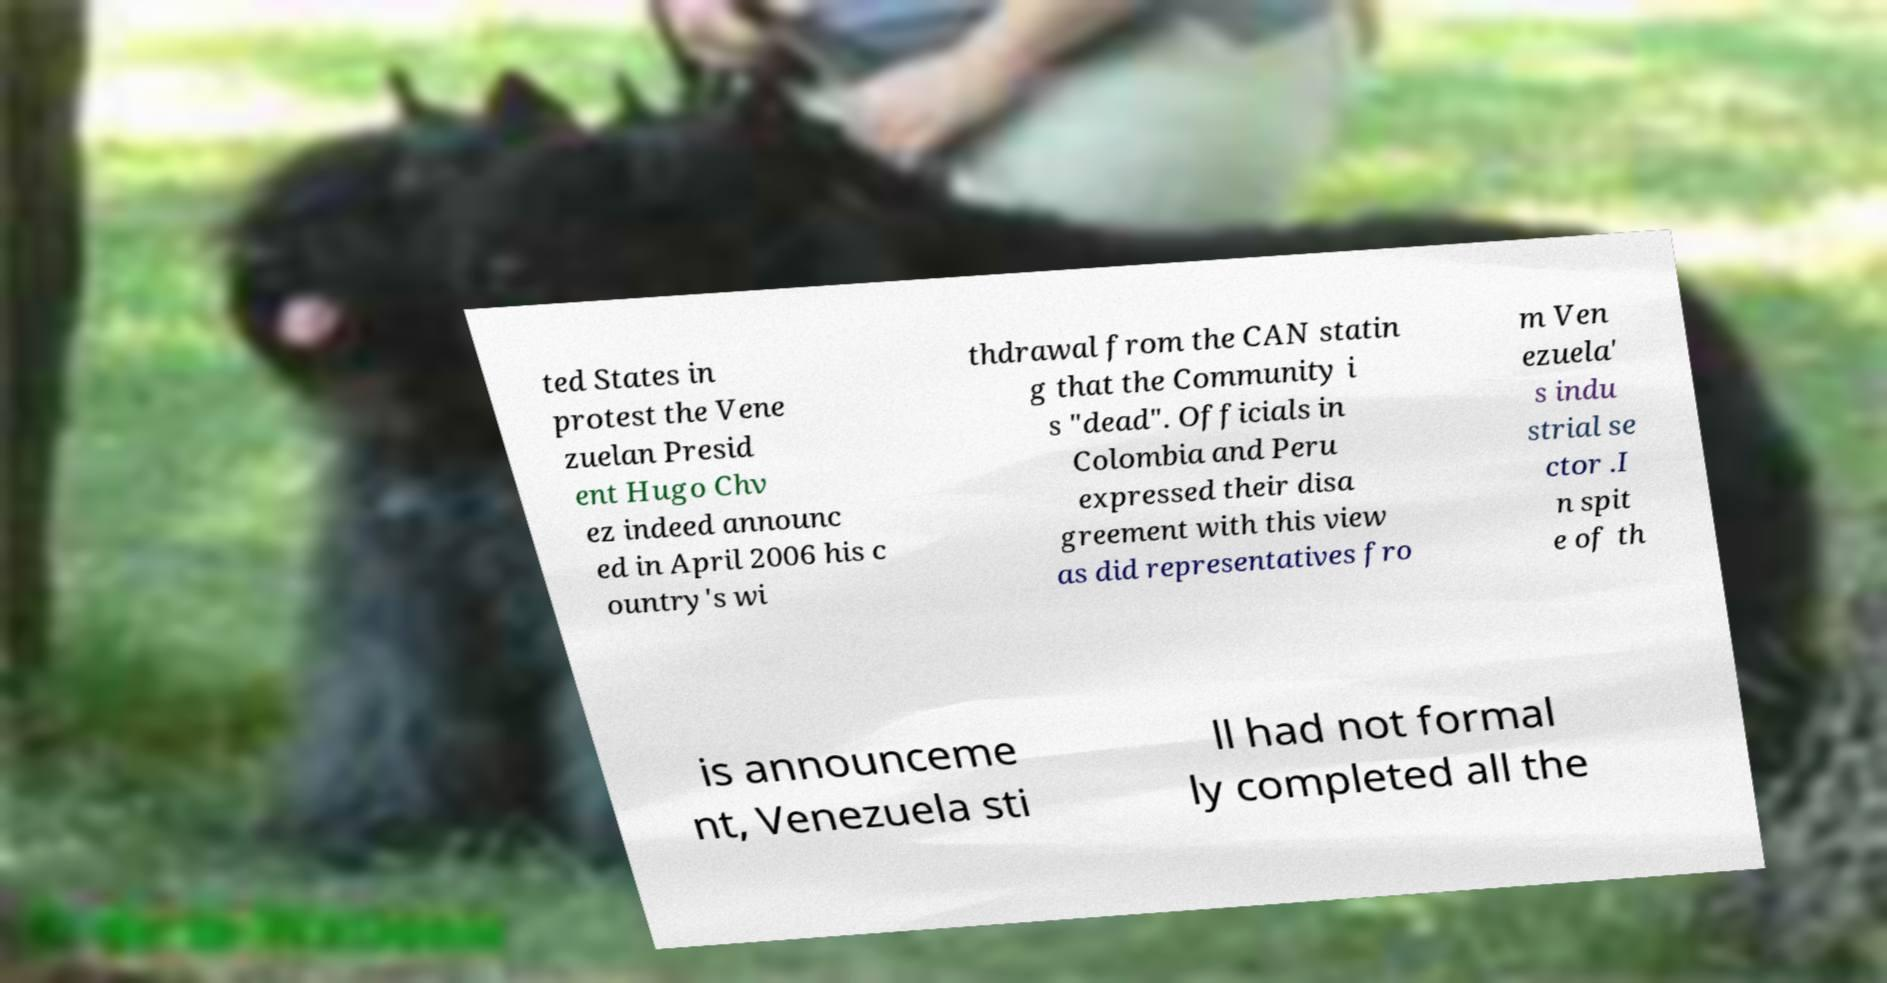Could you assist in decoding the text presented in this image and type it out clearly? ted States in protest the Vene zuelan Presid ent Hugo Chv ez indeed announc ed in April 2006 his c ountry's wi thdrawal from the CAN statin g that the Community i s "dead". Officials in Colombia and Peru expressed their disa greement with this view as did representatives fro m Ven ezuela' s indu strial se ctor .I n spit e of th is announceme nt, Venezuela sti ll had not formal ly completed all the 